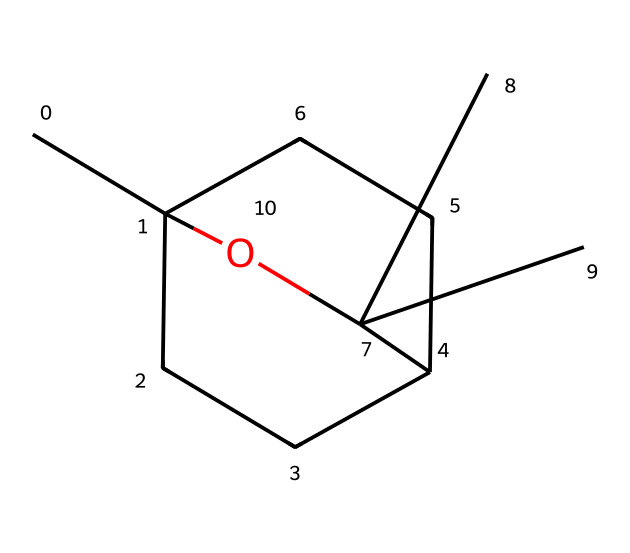What is the molecular formula of this compound? The SMILES representation provides the arrangement of atoms; from the structure, we can count the carbon (C), hydrogen (H), and oxygen (O) atoms. There are 10 carbon atoms, 18 hydrogen atoms, and 1 oxygen atom. Thus, the molecular formula is C10H18O.
Answer: C10H18O How many stereocenters does this molecule have? A stereocenter is a carbon atom that has four different substituents. By examining the structure, we can identify that there are two carbon atoms that are connected to four distinct groups, hence there are two stereocenters present.
Answer: 2 What type of functional group is present in eucalyptol? The presence of an -OH group in the chemical structure indicates that this compound contains an alcohol functional group. The hydroxyl group is a characteristic of alcohols.
Answer: alcohol What is the saturated ring structure indicated in the SMILES? The chemical structure contains a bicyclic ring system. The notation in the SMILES with the numbers indicates the connections forming a ring between different carbon atoms. Hence, we can conclude that it has a bicyclic structure.
Answer: bicyclic Why is eucalyptol considered an essential oil component? Essential oils are typically extracted from plants, and eucalyptol is derived from eucalyptus leaves. The structure of eucalyptol, which consists of a diverse arrangement of carbon and oxygen, contributes to its aromatic properties, categorizing it as an essential oil component.
Answer: aromatic properties How does the presence of the alcohol group affect the aroma of eucalyptol? The alcohol group has a significant influence on the volatility and scent profile of the compound, allowing it to interact with olfactory receptors more effectively. This structural feature enhances the overall aroma, contributing to its use in fragrances.
Answer: enhances aroma 